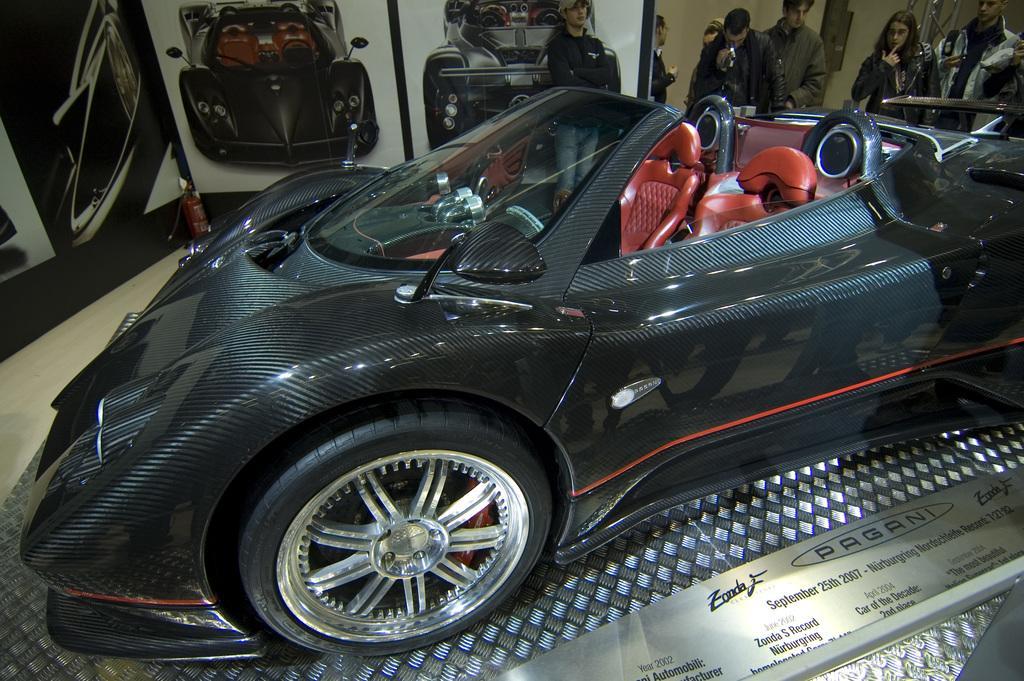How would you summarize this image in a sentence or two? In this picture we can see a car, some text on the platform and in the background we can see some people, fire extinguisher, photos of cars and some objects. 